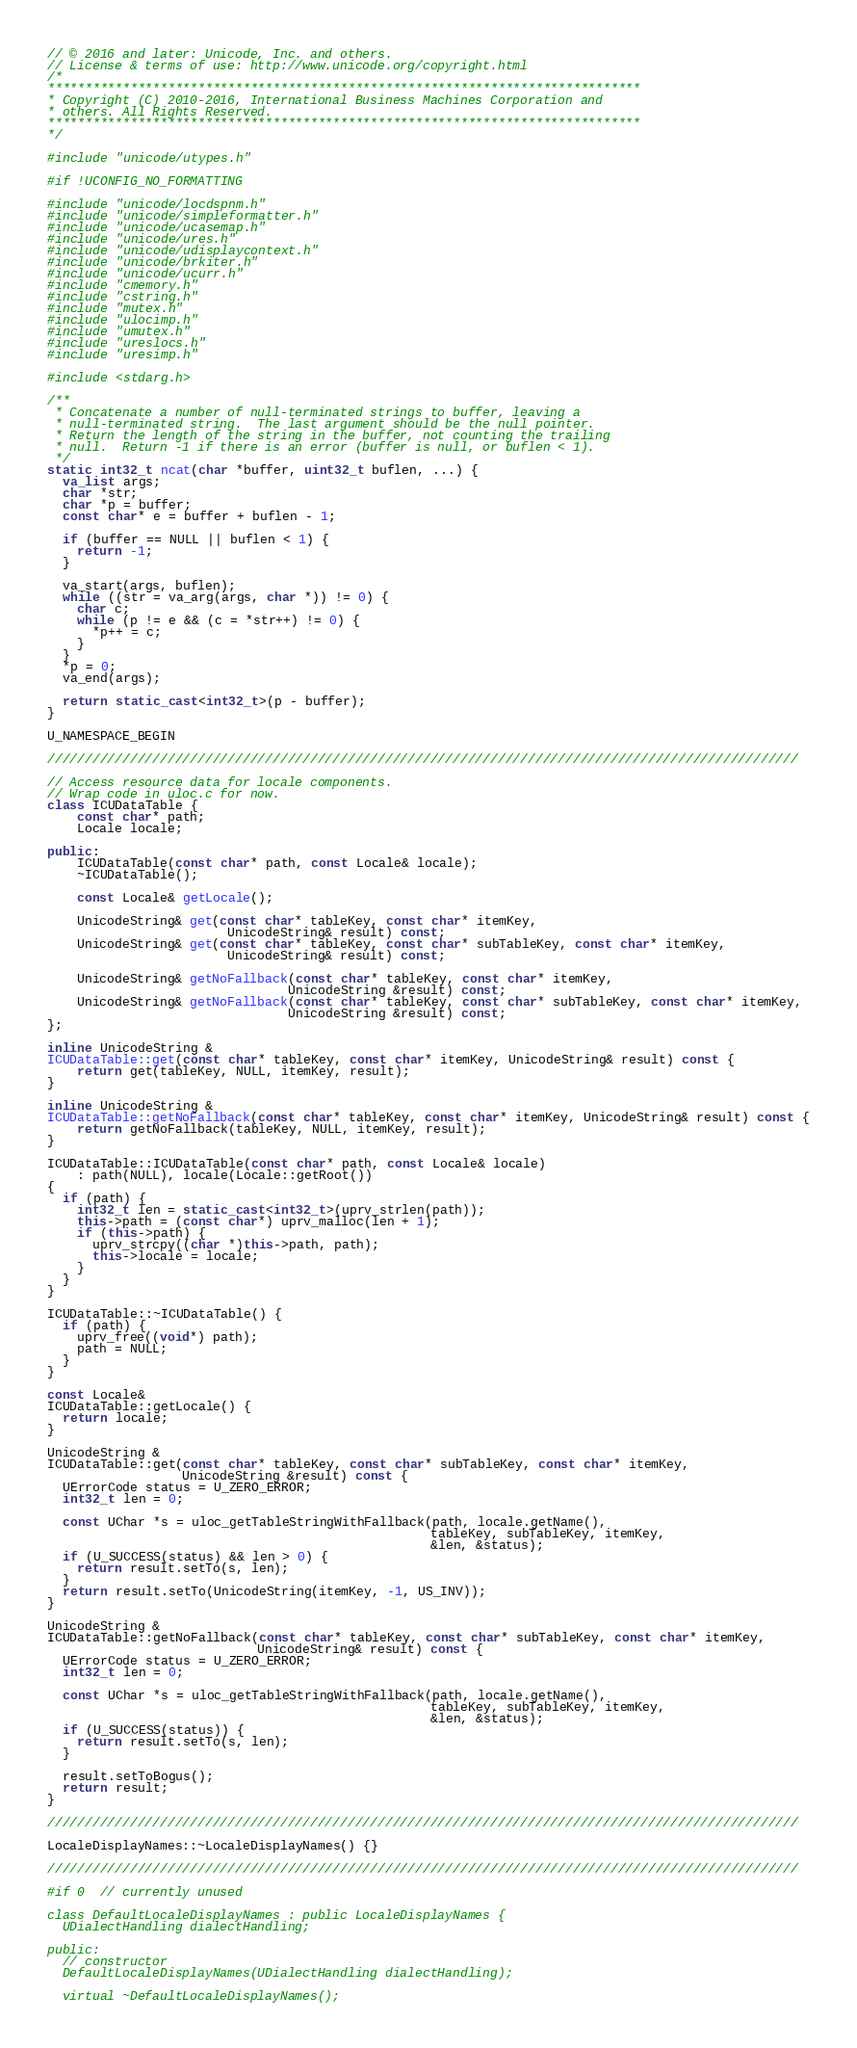<code> <loc_0><loc_0><loc_500><loc_500><_C++_>// © 2016 and later: Unicode, Inc. and others.
// License & terms of use: http://www.unicode.org/copyright.html
/*
*******************************************************************************
* Copyright (C) 2010-2016, International Business Machines Corporation and
* others. All Rights Reserved.
*******************************************************************************
*/

#include "unicode/utypes.h"

#if !UCONFIG_NO_FORMATTING

#include "unicode/locdspnm.h"
#include "unicode/simpleformatter.h"
#include "unicode/ucasemap.h"
#include "unicode/ures.h"
#include "unicode/udisplaycontext.h"
#include "unicode/brkiter.h"
#include "unicode/ucurr.h"
#include "cmemory.h"
#include "cstring.h"
#include "mutex.h"
#include "ulocimp.h"
#include "umutex.h"
#include "ureslocs.h"
#include "uresimp.h"

#include <stdarg.h>

/**
 * Concatenate a number of null-terminated strings to buffer, leaving a
 * null-terminated string.  The last argument should be the null pointer.
 * Return the length of the string in the buffer, not counting the trailing
 * null.  Return -1 if there is an error (buffer is null, or buflen < 1).
 */
static int32_t ncat(char *buffer, uint32_t buflen, ...) {
  va_list args;
  char *str;
  char *p = buffer;
  const char* e = buffer + buflen - 1;

  if (buffer == NULL || buflen < 1) {
    return -1;
  }

  va_start(args, buflen);
  while ((str = va_arg(args, char *)) != 0) {
    char c;
    while (p != e && (c = *str++) != 0) {
      *p++ = c;
    }
  }
  *p = 0;
  va_end(args);

  return static_cast<int32_t>(p - buffer);
}

U_NAMESPACE_BEGIN

////////////////////////////////////////////////////////////////////////////////////////////////////

// Access resource data for locale components.
// Wrap code in uloc.c for now.
class ICUDataTable {
    const char* path;
    Locale locale;

public:
    ICUDataTable(const char* path, const Locale& locale);
    ~ICUDataTable();

    const Locale& getLocale();

    UnicodeString& get(const char* tableKey, const char* itemKey,
                        UnicodeString& result) const;
    UnicodeString& get(const char* tableKey, const char* subTableKey, const char* itemKey,
                        UnicodeString& result) const;

    UnicodeString& getNoFallback(const char* tableKey, const char* itemKey,
                                UnicodeString &result) const;
    UnicodeString& getNoFallback(const char* tableKey, const char* subTableKey, const char* itemKey,
                                UnicodeString &result) const;
};

inline UnicodeString &
ICUDataTable::get(const char* tableKey, const char* itemKey, UnicodeString& result) const {
    return get(tableKey, NULL, itemKey, result);
}

inline UnicodeString &
ICUDataTable::getNoFallback(const char* tableKey, const char* itemKey, UnicodeString& result) const {
    return getNoFallback(tableKey, NULL, itemKey, result);
}

ICUDataTable::ICUDataTable(const char* path, const Locale& locale)
    : path(NULL), locale(Locale::getRoot())
{
  if (path) {
    int32_t len = static_cast<int32_t>(uprv_strlen(path));
    this->path = (const char*) uprv_malloc(len + 1);
    if (this->path) {
      uprv_strcpy((char *)this->path, path);
      this->locale = locale;
    }
  }
}

ICUDataTable::~ICUDataTable() {
  if (path) {
    uprv_free((void*) path);
    path = NULL;
  }
}

const Locale&
ICUDataTable::getLocale() {
  return locale;
}

UnicodeString &
ICUDataTable::get(const char* tableKey, const char* subTableKey, const char* itemKey,
                  UnicodeString &result) const {
  UErrorCode status = U_ZERO_ERROR;
  int32_t len = 0;

  const UChar *s = uloc_getTableStringWithFallback(path, locale.getName(),
                                                   tableKey, subTableKey, itemKey,
                                                   &len, &status);
  if (U_SUCCESS(status) && len > 0) {
    return result.setTo(s, len);
  }
  return result.setTo(UnicodeString(itemKey, -1, US_INV));
}

UnicodeString &
ICUDataTable::getNoFallback(const char* tableKey, const char* subTableKey, const char* itemKey,
                            UnicodeString& result) const {
  UErrorCode status = U_ZERO_ERROR;
  int32_t len = 0;

  const UChar *s = uloc_getTableStringWithFallback(path, locale.getName(),
                                                   tableKey, subTableKey, itemKey,
                                                   &len, &status);
  if (U_SUCCESS(status)) {
    return result.setTo(s, len);
  }

  result.setToBogus();
  return result;
}

////////////////////////////////////////////////////////////////////////////////////////////////////

LocaleDisplayNames::~LocaleDisplayNames() {}

////////////////////////////////////////////////////////////////////////////////////////////////////

#if 0  // currently unused

class DefaultLocaleDisplayNames : public LocaleDisplayNames {
  UDialectHandling dialectHandling;

public:
  // constructor
  DefaultLocaleDisplayNames(UDialectHandling dialectHandling);

  virtual ~DefaultLocaleDisplayNames();
</code> 